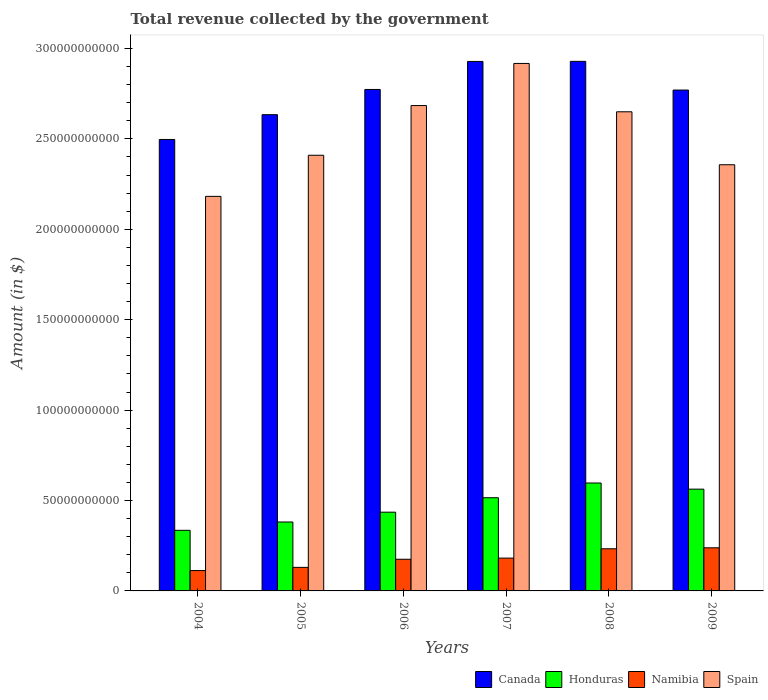How many groups of bars are there?
Offer a very short reply. 6. How many bars are there on the 4th tick from the right?
Your answer should be very brief. 4. What is the total revenue collected by the government in Spain in 2006?
Ensure brevity in your answer.  2.68e+11. Across all years, what is the maximum total revenue collected by the government in Canada?
Ensure brevity in your answer.  2.93e+11. Across all years, what is the minimum total revenue collected by the government in Honduras?
Your answer should be very brief. 3.35e+1. In which year was the total revenue collected by the government in Canada maximum?
Provide a short and direct response. 2008. In which year was the total revenue collected by the government in Canada minimum?
Your response must be concise. 2004. What is the total total revenue collected by the government in Honduras in the graph?
Ensure brevity in your answer.  2.83e+11. What is the difference between the total revenue collected by the government in Canada in 2004 and that in 2009?
Provide a succinct answer. -2.73e+1. What is the difference between the total revenue collected by the government in Canada in 2008 and the total revenue collected by the government in Namibia in 2009?
Offer a terse response. 2.69e+11. What is the average total revenue collected by the government in Spain per year?
Your answer should be very brief. 2.53e+11. In the year 2008, what is the difference between the total revenue collected by the government in Honduras and total revenue collected by the government in Spain?
Ensure brevity in your answer.  -2.05e+11. In how many years, is the total revenue collected by the government in Spain greater than 250000000000 $?
Give a very brief answer. 3. What is the ratio of the total revenue collected by the government in Spain in 2004 to that in 2006?
Keep it short and to the point. 0.81. Is the total revenue collected by the government in Honduras in 2006 less than that in 2008?
Your answer should be very brief. Yes. What is the difference between the highest and the second highest total revenue collected by the government in Spain?
Offer a terse response. 2.33e+1. What is the difference between the highest and the lowest total revenue collected by the government in Honduras?
Your response must be concise. 2.62e+1. What does the 4th bar from the left in 2009 represents?
Give a very brief answer. Spain. Is it the case that in every year, the sum of the total revenue collected by the government in Spain and total revenue collected by the government in Namibia is greater than the total revenue collected by the government in Canada?
Ensure brevity in your answer.  No. How many bars are there?
Offer a terse response. 24. Are all the bars in the graph horizontal?
Provide a succinct answer. No. How many years are there in the graph?
Provide a succinct answer. 6. Does the graph contain any zero values?
Offer a very short reply. No. Where does the legend appear in the graph?
Your answer should be very brief. Bottom right. What is the title of the graph?
Provide a short and direct response. Total revenue collected by the government. What is the label or title of the Y-axis?
Your answer should be very brief. Amount (in $). What is the Amount (in $) in Canada in 2004?
Give a very brief answer. 2.50e+11. What is the Amount (in $) of Honduras in 2004?
Make the answer very short. 3.35e+1. What is the Amount (in $) in Namibia in 2004?
Provide a succinct answer. 1.13e+1. What is the Amount (in $) of Spain in 2004?
Give a very brief answer. 2.18e+11. What is the Amount (in $) of Canada in 2005?
Offer a terse response. 2.63e+11. What is the Amount (in $) of Honduras in 2005?
Ensure brevity in your answer.  3.81e+1. What is the Amount (in $) of Namibia in 2005?
Provide a succinct answer. 1.30e+1. What is the Amount (in $) in Spain in 2005?
Provide a short and direct response. 2.41e+11. What is the Amount (in $) in Canada in 2006?
Your answer should be compact. 2.77e+11. What is the Amount (in $) of Honduras in 2006?
Provide a short and direct response. 4.35e+1. What is the Amount (in $) in Namibia in 2006?
Keep it short and to the point. 1.75e+1. What is the Amount (in $) in Spain in 2006?
Keep it short and to the point. 2.68e+11. What is the Amount (in $) in Canada in 2007?
Your response must be concise. 2.93e+11. What is the Amount (in $) in Honduras in 2007?
Offer a terse response. 5.15e+1. What is the Amount (in $) in Namibia in 2007?
Ensure brevity in your answer.  1.82e+1. What is the Amount (in $) in Spain in 2007?
Your answer should be compact. 2.92e+11. What is the Amount (in $) in Canada in 2008?
Your answer should be very brief. 2.93e+11. What is the Amount (in $) of Honduras in 2008?
Make the answer very short. 5.97e+1. What is the Amount (in $) in Namibia in 2008?
Offer a very short reply. 2.33e+1. What is the Amount (in $) of Spain in 2008?
Offer a terse response. 2.65e+11. What is the Amount (in $) in Canada in 2009?
Ensure brevity in your answer.  2.77e+11. What is the Amount (in $) of Honduras in 2009?
Give a very brief answer. 5.63e+1. What is the Amount (in $) of Namibia in 2009?
Ensure brevity in your answer.  2.38e+1. What is the Amount (in $) of Spain in 2009?
Your response must be concise. 2.36e+11. Across all years, what is the maximum Amount (in $) of Canada?
Provide a succinct answer. 2.93e+11. Across all years, what is the maximum Amount (in $) of Honduras?
Offer a terse response. 5.97e+1. Across all years, what is the maximum Amount (in $) in Namibia?
Your answer should be compact. 2.38e+1. Across all years, what is the maximum Amount (in $) in Spain?
Give a very brief answer. 2.92e+11. Across all years, what is the minimum Amount (in $) in Canada?
Provide a succinct answer. 2.50e+11. Across all years, what is the minimum Amount (in $) in Honduras?
Provide a succinct answer. 3.35e+1. Across all years, what is the minimum Amount (in $) of Namibia?
Give a very brief answer. 1.13e+1. Across all years, what is the minimum Amount (in $) in Spain?
Offer a very short reply. 2.18e+11. What is the total Amount (in $) of Canada in the graph?
Your answer should be very brief. 1.65e+12. What is the total Amount (in $) in Honduras in the graph?
Your response must be concise. 2.83e+11. What is the total Amount (in $) in Namibia in the graph?
Make the answer very short. 1.07e+11. What is the total Amount (in $) of Spain in the graph?
Give a very brief answer. 1.52e+12. What is the difference between the Amount (in $) of Canada in 2004 and that in 2005?
Make the answer very short. -1.37e+1. What is the difference between the Amount (in $) of Honduras in 2004 and that in 2005?
Your answer should be compact. -4.61e+09. What is the difference between the Amount (in $) in Namibia in 2004 and that in 2005?
Keep it short and to the point. -1.77e+09. What is the difference between the Amount (in $) of Spain in 2004 and that in 2005?
Your answer should be very brief. -2.27e+1. What is the difference between the Amount (in $) of Canada in 2004 and that in 2006?
Offer a very short reply. -2.77e+1. What is the difference between the Amount (in $) of Honduras in 2004 and that in 2006?
Your response must be concise. -1.00e+1. What is the difference between the Amount (in $) of Namibia in 2004 and that in 2006?
Offer a very short reply. -6.26e+09. What is the difference between the Amount (in $) in Spain in 2004 and that in 2006?
Keep it short and to the point. -5.02e+1. What is the difference between the Amount (in $) of Canada in 2004 and that in 2007?
Offer a very short reply. -4.32e+1. What is the difference between the Amount (in $) of Honduras in 2004 and that in 2007?
Keep it short and to the point. -1.80e+1. What is the difference between the Amount (in $) of Namibia in 2004 and that in 2007?
Make the answer very short. -6.89e+09. What is the difference between the Amount (in $) in Spain in 2004 and that in 2007?
Your answer should be very brief. -7.35e+1. What is the difference between the Amount (in $) of Canada in 2004 and that in 2008?
Your answer should be compact. -4.32e+1. What is the difference between the Amount (in $) of Honduras in 2004 and that in 2008?
Offer a very short reply. -2.62e+1. What is the difference between the Amount (in $) in Namibia in 2004 and that in 2008?
Make the answer very short. -1.21e+1. What is the difference between the Amount (in $) in Spain in 2004 and that in 2008?
Provide a short and direct response. -4.68e+1. What is the difference between the Amount (in $) in Canada in 2004 and that in 2009?
Give a very brief answer. -2.73e+1. What is the difference between the Amount (in $) in Honduras in 2004 and that in 2009?
Give a very brief answer. -2.28e+1. What is the difference between the Amount (in $) of Namibia in 2004 and that in 2009?
Provide a succinct answer. -1.26e+1. What is the difference between the Amount (in $) in Spain in 2004 and that in 2009?
Offer a terse response. -1.75e+1. What is the difference between the Amount (in $) of Canada in 2005 and that in 2006?
Provide a succinct answer. -1.40e+1. What is the difference between the Amount (in $) of Honduras in 2005 and that in 2006?
Provide a short and direct response. -5.42e+09. What is the difference between the Amount (in $) of Namibia in 2005 and that in 2006?
Offer a terse response. -4.49e+09. What is the difference between the Amount (in $) in Spain in 2005 and that in 2006?
Offer a very short reply. -2.75e+1. What is the difference between the Amount (in $) of Canada in 2005 and that in 2007?
Offer a very short reply. -2.94e+1. What is the difference between the Amount (in $) of Honduras in 2005 and that in 2007?
Offer a very short reply. -1.34e+1. What is the difference between the Amount (in $) in Namibia in 2005 and that in 2007?
Your answer should be very brief. -5.12e+09. What is the difference between the Amount (in $) in Spain in 2005 and that in 2007?
Offer a terse response. -5.08e+1. What is the difference between the Amount (in $) of Canada in 2005 and that in 2008?
Make the answer very short. -2.95e+1. What is the difference between the Amount (in $) of Honduras in 2005 and that in 2008?
Keep it short and to the point. -2.16e+1. What is the difference between the Amount (in $) in Namibia in 2005 and that in 2008?
Your answer should be compact. -1.03e+1. What is the difference between the Amount (in $) in Spain in 2005 and that in 2008?
Offer a terse response. -2.40e+1. What is the difference between the Amount (in $) of Canada in 2005 and that in 2009?
Your answer should be very brief. -1.36e+1. What is the difference between the Amount (in $) in Honduras in 2005 and that in 2009?
Give a very brief answer. -1.82e+1. What is the difference between the Amount (in $) in Namibia in 2005 and that in 2009?
Ensure brevity in your answer.  -1.08e+1. What is the difference between the Amount (in $) of Spain in 2005 and that in 2009?
Provide a short and direct response. 5.25e+09. What is the difference between the Amount (in $) in Canada in 2006 and that in 2007?
Your response must be concise. -1.55e+1. What is the difference between the Amount (in $) of Honduras in 2006 and that in 2007?
Ensure brevity in your answer.  -7.99e+09. What is the difference between the Amount (in $) in Namibia in 2006 and that in 2007?
Provide a succinct answer. -6.34e+08. What is the difference between the Amount (in $) in Spain in 2006 and that in 2007?
Keep it short and to the point. -2.33e+1. What is the difference between the Amount (in $) in Canada in 2006 and that in 2008?
Your response must be concise. -1.55e+1. What is the difference between the Amount (in $) in Honduras in 2006 and that in 2008?
Keep it short and to the point. -1.61e+1. What is the difference between the Amount (in $) of Namibia in 2006 and that in 2008?
Offer a very short reply. -5.80e+09. What is the difference between the Amount (in $) of Spain in 2006 and that in 2008?
Make the answer very short. 3.45e+09. What is the difference between the Amount (in $) of Canada in 2006 and that in 2009?
Provide a short and direct response. 3.30e+08. What is the difference between the Amount (in $) of Honduras in 2006 and that in 2009?
Your answer should be compact. -1.27e+1. What is the difference between the Amount (in $) in Namibia in 2006 and that in 2009?
Your response must be concise. -6.33e+09. What is the difference between the Amount (in $) in Spain in 2006 and that in 2009?
Offer a very short reply. 3.27e+1. What is the difference between the Amount (in $) of Canada in 2007 and that in 2008?
Offer a terse response. -5.20e+07. What is the difference between the Amount (in $) of Honduras in 2007 and that in 2008?
Ensure brevity in your answer.  -8.15e+09. What is the difference between the Amount (in $) in Namibia in 2007 and that in 2008?
Your answer should be very brief. -5.16e+09. What is the difference between the Amount (in $) in Spain in 2007 and that in 2008?
Offer a terse response. 2.67e+1. What is the difference between the Amount (in $) of Canada in 2007 and that in 2009?
Keep it short and to the point. 1.58e+1. What is the difference between the Amount (in $) in Honduras in 2007 and that in 2009?
Offer a very short reply. -4.75e+09. What is the difference between the Amount (in $) of Namibia in 2007 and that in 2009?
Make the answer very short. -5.70e+09. What is the difference between the Amount (in $) of Spain in 2007 and that in 2009?
Give a very brief answer. 5.60e+1. What is the difference between the Amount (in $) in Canada in 2008 and that in 2009?
Provide a succinct answer. 1.59e+1. What is the difference between the Amount (in $) in Honduras in 2008 and that in 2009?
Keep it short and to the point. 3.40e+09. What is the difference between the Amount (in $) in Namibia in 2008 and that in 2009?
Ensure brevity in your answer.  -5.30e+08. What is the difference between the Amount (in $) in Spain in 2008 and that in 2009?
Give a very brief answer. 2.93e+1. What is the difference between the Amount (in $) of Canada in 2004 and the Amount (in $) of Honduras in 2005?
Offer a terse response. 2.12e+11. What is the difference between the Amount (in $) in Canada in 2004 and the Amount (in $) in Namibia in 2005?
Your answer should be very brief. 2.37e+11. What is the difference between the Amount (in $) in Canada in 2004 and the Amount (in $) in Spain in 2005?
Your response must be concise. 8.73e+09. What is the difference between the Amount (in $) in Honduras in 2004 and the Amount (in $) in Namibia in 2005?
Your response must be concise. 2.05e+1. What is the difference between the Amount (in $) of Honduras in 2004 and the Amount (in $) of Spain in 2005?
Your answer should be compact. -2.07e+11. What is the difference between the Amount (in $) in Namibia in 2004 and the Amount (in $) in Spain in 2005?
Offer a very short reply. -2.30e+11. What is the difference between the Amount (in $) in Canada in 2004 and the Amount (in $) in Honduras in 2006?
Your answer should be compact. 2.06e+11. What is the difference between the Amount (in $) of Canada in 2004 and the Amount (in $) of Namibia in 2006?
Give a very brief answer. 2.32e+11. What is the difference between the Amount (in $) in Canada in 2004 and the Amount (in $) in Spain in 2006?
Provide a short and direct response. -1.88e+1. What is the difference between the Amount (in $) in Honduras in 2004 and the Amount (in $) in Namibia in 2006?
Give a very brief answer. 1.60e+1. What is the difference between the Amount (in $) in Honduras in 2004 and the Amount (in $) in Spain in 2006?
Provide a short and direct response. -2.35e+11. What is the difference between the Amount (in $) of Namibia in 2004 and the Amount (in $) of Spain in 2006?
Your answer should be compact. -2.57e+11. What is the difference between the Amount (in $) of Canada in 2004 and the Amount (in $) of Honduras in 2007?
Keep it short and to the point. 1.98e+11. What is the difference between the Amount (in $) in Canada in 2004 and the Amount (in $) in Namibia in 2007?
Provide a short and direct response. 2.32e+11. What is the difference between the Amount (in $) in Canada in 2004 and the Amount (in $) in Spain in 2007?
Your answer should be compact. -4.21e+1. What is the difference between the Amount (in $) of Honduras in 2004 and the Amount (in $) of Namibia in 2007?
Offer a very short reply. 1.54e+1. What is the difference between the Amount (in $) of Honduras in 2004 and the Amount (in $) of Spain in 2007?
Your response must be concise. -2.58e+11. What is the difference between the Amount (in $) in Namibia in 2004 and the Amount (in $) in Spain in 2007?
Your answer should be compact. -2.80e+11. What is the difference between the Amount (in $) in Canada in 2004 and the Amount (in $) in Honduras in 2008?
Offer a very short reply. 1.90e+11. What is the difference between the Amount (in $) in Canada in 2004 and the Amount (in $) in Namibia in 2008?
Make the answer very short. 2.26e+11. What is the difference between the Amount (in $) in Canada in 2004 and the Amount (in $) in Spain in 2008?
Keep it short and to the point. -1.53e+1. What is the difference between the Amount (in $) in Honduras in 2004 and the Amount (in $) in Namibia in 2008?
Provide a short and direct response. 1.02e+1. What is the difference between the Amount (in $) in Honduras in 2004 and the Amount (in $) in Spain in 2008?
Make the answer very short. -2.31e+11. What is the difference between the Amount (in $) of Namibia in 2004 and the Amount (in $) of Spain in 2008?
Your response must be concise. -2.54e+11. What is the difference between the Amount (in $) of Canada in 2004 and the Amount (in $) of Honduras in 2009?
Keep it short and to the point. 1.93e+11. What is the difference between the Amount (in $) in Canada in 2004 and the Amount (in $) in Namibia in 2009?
Your response must be concise. 2.26e+11. What is the difference between the Amount (in $) of Canada in 2004 and the Amount (in $) of Spain in 2009?
Your answer should be very brief. 1.40e+1. What is the difference between the Amount (in $) of Honduras in 2004 and the Amount (in $) of Namibia in 2009?
Keep it short and to the point. 9.67e+09. What is the difference between the Amount (in $) in Honduras in 2004 and the Amount (in $) in Spain in 2009?
Your response must be concise. -2.02e+11. What is the difference between the Amount (in $) of Namibia in 2004 and the Amount (in $) of Spain in 2009?
Your answer should be very brief. -2.24e+11. What is the difference between the Amount (in $) in Canada in 2005 and the Amount (in $) in Honduras in 2006?
Your response must be concise. 2.20e+11. What is the difference between the Amount (in $) in Canada in 2005 and the Amount (in $) in Namibia in 2006?
Give a very brief answer. 2.46e+11. What is the difference between the Amount (in $) of Canada in 2005 and the Amount (in $) of Spain in 2006?
Your response must be concise. -5.04e+09. What is the difference between the Amount (in $) in Honduras in 2005 and the Amount (in $) in Namibia in 2006?
Give a very brief answer. 2.06e+1. What is the difference between the Amount (in $) in Honduras in 2005 and the Amount (in $) in Spain in 2006?
Keep it short and to the point. -2.30e+11. What is the difference between the Amount (in $) in Namibia in 2005 and the Amount (in $) in Spain in 2006?
Offer a very short reply. -2.55e+11. What is the difference between the Amount (in $) in Canada in 2005 and the Amount (in $) in Honduras in 2007?
Keep it short and to the point. 2.12e+11. What is the difference between the Amount (in $) of Canada in 2005 and the Amount (in $) of Namibia in 2007?
Your response must be concise. 2.45e+11. What is the difference between the Amount (in $) in Canada in 2005 and the Amount (in $) in Spain in 2007?
Ensure brevity in your answer.  -2.83e+1. What is the difference between the Amount (in $) in Honduras in 2005 and the Amount (in $) in Namibia in 2007?
Your response must be concise. 2.00e+1. What is the difference between the Amount (in $) of Honduras in 2005 and the Amount (in $) of Spain in 2007?
Keep it short and to the point. -2.54e+11. What is the difference between the Amount (in $) in Namibia in 2005 and the Amount (in $) in Spain in 2007?
Provide a succinct answer. -2.79e+11. What is the difference between the Amount (in $) in Canada in 2005 and the Amount (in $) in Honduras in 2008?
Your answer should be very brief. 2.04e+11. What is the difference between the Amount (in $) of Canada in 2005 and the Amount (in $) of Namibia in 2008?
Offer a terse response. 2.40e+11. What is the difference between the Amount (in $) in Canada in 2005 and the Amount (in $) in Spain in 2008?
Ensure brevity in your answer.  -1.60e+09. What is the difference between the Amount (in $) of Honduras in 2005 and the Amount (in $) of Namibia in 2008?
Offer a very short reply. 1.48e+1. What is the difference between the Amount (in $) of Honduras in 2005 and the Amount (in $) of Spain in 2008?
Offer a terse response. -2.27e+11. What is the difference between the Amount (in $) of Namibia in 2005 and the Amount (in $) of Spain in 2008?
Provide a succinct answer. -2.52e+11. What is the difference between the Amount (in $) in Canada in 2005 and the Amount (in $) in Honduras in 2009?
Your answer should be compact. 2.07e+11. What is the difference between the Amount (in $) of Canada in 2005 and the Amount (in $) of Namibia in 2009?
Provide a short and direct response. 2.40e+11. What is the difference between the Amount (in $) in Canada in 2005 and the Amount (in $) in Spain in 2009?
Keep it short and to the point. 2.77e+1. What is the difference between the Amount (in $) of Honduras in 2005 and the Amount (in $) of Namibia in 2009?
Offer a terse response. 1.43e+1. What is the difference between the Amount (in $) of Honduras in 2005 and the Amount (in $) of Spain in 2009?
Provide a succinct answer. -1.98e+11. What is the difference between the Amount (in $) in Namibia in 2005 and the Amount (in $) in Spain in 2009?
Ensure brevity in your answer.  -2.23e+11. What is the difference between the Amount (in $) of Canada in 2006 and the Amount (in $) of Honduras in 2007?
Keep it short and to the point. 2.26e+11. What is the difference between the Amount (in $) of Canada in 2006 and the Amount (in $) of Namibia in 2007?
Ensure brevity in your answer.  2.59e+11. What is the difference between the Amount (in $) of Canada in 2006 and the Amount (in $) of Spain in 2007?
Give a very brief answer. -1.44e+1. What is the difference between the Amount (in $) in Honduras in 2006 and the Amount (in $) in Namibia in 2007?
Make the answer very short. 2.54e+1. What is the difference between the Amount (in $) in Honduras in 2006 and the Amount (in $) in Spain in 2007?
Keep it short and to the point. -2.48e+11. What is the difference between the Amount (in $) in Namibia in 2006 and the Amount (in $) in Spain in 2007?
Offer a terse response. -2.74e+11. What is the difference between the Amount (in $) of Canada in 2006 and the Amount (in $) of Honduras in 2008?
Ensure brevity in your answer.  2.18e+11. What is the difference between the Amount (in $) in Canada in 2006 and the Amount (in $) in Namibia in 2008?
Offer a very short reply. 2.54e+11. What is the difference between the Amount (in $) of Canada in 2006 and the Amount (in $) of Spain in 2008?
Your answer should be compact. 1.24e+1. What is the difference between the Amount (in $) in Honduras in 2006 and the Amount (in $) in Namibia in 2008?
Offer a very short reply. 2.02e+1. What is the difference between the Amount (in $) in Honduras in 2006 and the Amount (in $) in Spain in 2008?
Offer a terse response. -2.21e+11. What is the difference between the Amount (in $) in Namibia in 2006 and the Amount (in $) in Spain in 2008?
Keep it short and to the point. -2.47e+11. What is the difference between the Amount (in $) in Canada in 2006 and the Amount (in $) in Honduras in 2009?
Provide a succinct answer. 2.21e+11. What is the difference between the Amount (in $) in Canada in 2006 and the Amount (in $) in Namibia in 2009?
Make the answer very short. 2.54e+11. What is the difference between the Amount (in $) in Canada in 2006 and the Amount (in $) in Spain in 2009?
Offer a very short reply. 4.16e+1. What is the difference between the Amount (in $) of Honduras in 2006 and the Amount (in $) of Namibia in 2009?
Keep it short and to the point. 1.97e+1. What is the difference between the Amount (in $) in Honduras in 2006 and the Amount (in $) in Spain in 2009?
Your answer should be compact. -1.92e+11. What is the difference between the Amount (in $) of Namibia in 2006 and the Amount (in $) of Spain in 2009?
Offer a very short reply. -2.18e+11. What is the difference between the Amount (in $) of Canada in 2007 and the Amount (in $) of Honduras in 2008?
Your answer should be very brief. 2.33e+11. What is the difference between the Amount (in $) in Canada in 2007 and the Amount (in $) in Namibia in 2008?
Give a very brief answer. 2.70e+11. What is the difference between the Amount (in $) of Canada in 2007 and the Amount (in $) of Spain in 2008?
Offer a very short reply. 2.78e+1. What is the difference between the Amount (in $) of Honduras in 2007 and the Amount (in $) of Namibia in 2008?
Make the answer very short. 2.82e+1. What is the difference between the Amount (in $) in Honduras in 2007 and the Amount (in $) in Spain in 2008?
Provide a short and direct response. -2.13e+11. What is the difference between the Amount (in $) in Namibia in 2007 and the Amount (in $) in Spain in 2008?
Give a very brief answer. -2.47e+11. What is the difference between the Amount (in $) of Canada in 2007 and the Amount (in $) of Honduras in 2009?
Your answer should be very brief. 2.37e+11. What is the difference between the Amount (in $) in Canada in 2007 and the Amount (in $) in Namibia in 2009?
Ensure brevity in your answer.  2.69e+11. What is the difference between the Amount (in $) in Canada in 2007 and the Amount (in $) in Spain in 2009?
Your answer should be very brief. 5.71e+1. What is the difference between the Amount (in $) of Honduras in 2007 and the Amount (in $) of Namibia in 2009?
Provide a succinct answer. 2.77e+1. What is the difference between the Amount (in $) in Honduras in 2007 and the Amount (in $) in Spain in 2009?
Offer a terse response. -1.84e+11. What is the difference between the Amount (in $) of Namibia in 2007 and the Amount (in $) of Spain in 2009?
Offer a very short reply. -2.18e+11. What is the difference between the Amount (in $) of Canada in 2008 and the Amount (in $) of Honduras in 2009?
Provide a succinct answer. 2.37e+11. What is the difference between the Amount (in $) of Canada in 2008 and the Amount (in $) of Namibia in 2009?
Make the answer very short. 2.69e+11. What is the difference between the Amount (in $) of Canada in 2008 and the Amount (in $) of Spain in 2009?
Keep it short and to the point. 5.72e+1. What is the difference between the Amount (in $) of Honduras in 2008 and the Amount (in $) of Namibia in 2009?
Offer a terse response. 3.58e+1. What is the difference between the Amount (in $) of Honduras in 2008 and the Amount (in $) of Spain in 2009?
Your response must be concise. -1.76e+11. What is the difference between the Amount (in $) in Namibia in 2008 and the Amount (in $) in Spain in 2009?
Provide a succinct answer. -2.12e+11. What is the average Amount (in $) in Canada per year?
Your response must be concise. 2.76e+11. What is the average Amount (in $) of Honduras per year?
Ensure brevity in your answer.  4.71e+1. What is the average Amount (in $) of Namibia per year?
Offer a terse response. 1.79e+1. What is the average Amount (in $) of Spain per year?
Provide a short and direct response. 2.53e+11. In the year 2004, what is the difference between the Amount (in $) of Canada and Amount (in $) of Honduras?
Ensure brevity in your answer.  2.16e+11. In the year 2004, what is the difference between the Amount (in $) of Canada and Amount (in $) of Namibia?
Your answer should be very brief. 2.38e+11. In the year 2004, what is the difference between the Amount (in $) in Canada and Amount (in $) in Spain?
Make the answer very short. 3.15e+1. In the year 2004, what is the difference between the Amount (in $) in Honduras and Amount (in $) in Namibia?
Keep it short and to the point. 2.23e+1. In the year 2004, what is the difference between the Amount (in $) in Honduras and Amount (in $) in Spain?
Make the answer very short. -1.85e+11. In the year 2004, what is the difference between the Amount (in $) in Namibia and Amount (in $) in Spain?
Keep it short and to the point. -2.07e+11. In the year 2005, what is the difference between the Amount (in $) in Canada and Amount (in $) in Honduras?
Provide a short and direct response. 2.25e+11. In the year 2005, what is the difference between the Amount (in $) of Canada and Amount (in $) of Namibia?
Keep it short and to the point. 2.50e+11. In the year 2005, what is the difference between the Amount (in $) in Canada and Amount (in $) in Spain?
Make the answer very short. 2.24e+1. In the year 2005, what is the difference between the Amount (in $) of Honduras and Amount (in $) of Namibia?
Your answer should be compact. 2.51e+1. In the year 2005, what is the difference between the Amount (in $) of Honduras and Amount (in $) of Spain?
Give a very brief answer. -2.03e+11. In the year 2005, what is the difference between the Amount (in $) of Namibia and Amount (in $) of Spain?
Keep it short and to the point. -2.28e+11. In the year 2006, what is the difference between the Amount (in $) of Canada and Amount (in $) of Honduras?
Your response must be concise. 2.34e+11. In the year 2006, what is the difference between the Amount (in $) in Canada and Amount (in $) in Namibia?
Provide a short and direct response. 2.60e+11. In the year 2006, what is the difference between the Amount (in $) in Canada and Amount (in $) in Spain?
Offer a very short reply. 8.91e+09. In the year 2006, what is the difference between the Amount (in $) in Honduras and Amount (in $) in Namibia?
Ensure brevity in your answer.  2.60e+1. In the year 2006, what is the difference between the Amount (in $) of Honduras and Amount (in $) of Spain?
Your answer should be compact. -2.25e+11. In the year 2006, what is the difference between the Amount (in $) of Namibia and Amount (in $) of Spain?
Make the answer very short. -2.51e+11. In the year 2007, what is the difference between the Amount (in $) of Canada and Amount (in $) of Honduras?
Keep it short and to the point. 2.41e+11. In the year 2007, what is the difference between the Amount (in $) in Canada and Amount (in $) in Namibia?
Give a very brief answer. 2.75e+11. In the year 2007, what is the difference between the Amount (in $) of Canada and Amount (in $) of Spain?
Your answer should be very brief. 1.10e+09. In the year 2007, what is the difference between the Amount (in $) in Honduras and Amount (in $) in Namibia?
Your response must be concise. 3.34e+1. In the year 2007, what is the difference between the Amount (in $) in Honduras and Amount (in $) in Spain?
Your response must be concise. -2.40e+11. In the year 2007, what is the difference between the Amount (in $) of Namibia and Amount (in $) of Spain?
Keep it short and to the point. -2.74e+11. In the year 2008, what is the difference between the Amount (in $) of Canada and Amount (in $) of Honduras?
Provide a short and direct response. 2.33e+11. In the year 2008, what is the difference between the Amount (in $) in Canada and Amount (in $) in Namibia?
Provide a succinct answer. 2.70e+11. In the year 2008, what is the difference between the Amount (in $) of Canada and Amount (in $) of Spain?
Offer a very short reply. 2.79e+1. In the year 2008, what is the difference between the Amount (in $) in Honduras and Amount (in $) in Namibia?
Offer a very short reply. 3.64e+1. In the year 2008, what is the difference between the Amount (in $) in Honduras and Amount (in $) in Spain?
Make the answer very short. -2.05e+11. In the year 2008, what is the difference between the Amount (in $) in Namibia and Amount (in $) in Spain?
Keep it short and to the point. -2.42e+11. In the year 2009, what is the difference between the Amount (in $) in Canada and Amount (in $) in Honduras?
Your answer should be compact. 2.21e+11. In the year 2009, what is the difference between the Amount (in $) in Canada and Amount (in $) in Namibia?
Give a very brief answer. 2.53e+11. In the year 2009, what is the difference between the Amount (in $) of Canada and Amount (in $) of Spain?
Your answer should be compact. 4.13e+1. In the year 2009, what is the difference between the Amount (in $) in Honduras and Amount (in $) in Namibia?
Ensure brevity in your answer.  3.24e+1. In the year 2009, what is the difference between the Amount (in $) of Honduras and Amount (in $) of Spain?
Your answer should be very brief. -1.79e+11. In the year 2009, what is the difference between the Amount (in $) in Namibia and Amount (in $) in Spain?
Ensure brevity in your answer.  -2.12e+11. What is the ratio of the Amount (in $) of Canada in 2004 to that in 2005?
Provide a short and direct response. 0.95. What is the ratio of the Amount (in $) in Honduras in 2004 to that in 2005?
Provide a succinct answer. 0.88. What is the ratio of the Amount (in $) in Namibia in 2004 to that in 2005?
Give a very brief answer. 0.86. What is the ratio of the Amount (in $) of Spain in 2004 to that in 2005?
Keep it short and to the point. 0.91. What is the ratio of the Amount (in $) of Canada in 2004 to that in 2006?
Give a very brief answer. 0.9. What is the ratio of the Amount (in $) of Honduras in 2004 to that in 2006?
Provide a succinct answer. 0.77. What is the ratio of the Amount (in $) of Namibia in 2004 to that in 2006?
Your answer should be very brief. 0.64. What is the ratio of the Amount (in $) in Spain in 2004 to that in 2006?
Provide a succinct answer. 0.81. What is the ratio of the Amount (in $) of Canada in 2004 to that in 2007?
Offer a very short reply. 0.85. What is the ratio of the Amount (in $) of Honduras in 2004 to that in 2007?
Ensure brevity in your answer.  0.65. What is the ratio of the Amount (in $) in Namibia in 2004 to that in 2007?
Give a very brief answer. 0.62. What is the ratio of the Amount (in $) of Spain in 2004 to that in 2007?
Offer a terse response. 0.75. What is the ratio of the Amount (in $) in Canada in 2004 to that in 2008?
Your response must be concise. 0.85. What is the ratio of the Amount (in $) of Honduras in 2004 to that in 2008?
Your response must be concise. 0.56. What is the ratio of the Amount (in $) of Namibia in 2004 to that in 2008?
Make the answer very short. 0.48. What is the ratio of the Amount (in $) of Spain in 2004 to that in 2008?
Your answer should be compact. 0.82. What is the ratio of the Amount (in $) of Canada in 2004 to that in 2009?
Your response must be concise. 0.9. What is the ratio of the Amount (in $) in Honduras in 2004 to that in 2009?
Give a very brief answer. 0.6. What is the ratio of the Amount (in $) in Namibia in 2004 to that in 2009?
Make the answer very short. 0.47. What is the ratio of the Amount (in $) in Spain in 2004 to that in 2009?
Ensure brevity in your answer.  0.93. What is the ratio of the Amount (in $) in Canada in 2005 to that in 2006?
Provide a succinct answer. 0.95. What is the ratio of the Amount (in $) of Honduras in 2005 to that in 2006?
Your answer should be very brief. 0.88. What is the ratio of the Amount (in $) in Namibia in 2005 to that in 2006?
Your answer should be very brief. 0.74. What is the ratio of the Amount (in $) in Spain in 2005 to that in 2006?
Ensure brevity in your answer.  0.9. What is the ratio of the Amount (in $) of Canada in 2005 to that in 2007?
Give a very brief answer. 0.9. What is the ratio of the Amount (in $) of Honduras in 2005 to that in 2007?
Your answer should be compact. 0.74. What is the ratio of the Amount (in $) in Namibia in 2005 to that in 2007?
Offer a terse response. 0.72. What is the ratio of the Amount (in $) in Spain in 2005 to that in 2007?
Give a very brief answer. 0.83. What is the ratio of the Amount (in $) of Canada in 2005 to that in 2008?
Your response must be concise. 0.9. What is the ratio of the Amount (in $) of Honduras in 2005 to that in 2008?
Give a very brief answer. 0.64. What is the ratio of the Amount (in $) of Namibia in 2005 to that in 2008?
Provide a short and direct response. 0.56. What is the ratio of the Amount (in $) in Spain in 2005 to that in 2008?
Provide a short and direct response. 0.91. What is the ratio of the Amount (in $) of Canada in 2005 to that in 2009?
Keep it short and to the point. 0.95. What is the ratio of the Amount (in $) in Honduras in 2005 to that in 2009?
Offer a very short reply. 0.68. What is the ratio of the Amount (in $) of Namibia in 2005 to that in 2009?
Your answer should be compact. 0.55. What is the ratio of the Amount (in $) in Spain in 2005 to that in 2009?
Your answer should be very brief. 1.02. What is the ratio of the Amount (in $) of Canada in 2006 to that in 2007?
Offer a very short reply. 0.95. What is the ratio of the Amount (in $) in Honduras in 2006 to that in 2007?
Offer a very short reply. 0.84. What is the ratio of the Amount (in $) of Namibia in 2006 to that in 2007?
Provide a short and direct response. 0.97. What is the ratio of the Amount (in $) in Spain in 2006 to that in 2007?
Provide a succinct answer. 0.92. What is the ratio of the Amount (in $) in Canada in 2006 to that in 2008?
Give a very brief answer. 0.95. What is the ratio of the Amount (in $) of Honduras in 2006 to that in 2008?
Your response must be concise. 0.73. What is the ratio of the Amount (in $) of Namibia in 2006 to that in 2008?
Offer a terse response. 0.75. What is the ratio of the Amount (in $) of Spain in 2006 to that in 2008?
Your answer should be compact. 1.01. What is the ratio of the Amount (in $) of Honduras in 2006 to that in 2009?
Provide a short and direct response. 0.77. What is the ratio of the Amount (in $) in Namibia in 2006 to that in 2009?
Your answer should be compact. 0.73. What is the ratio of the Amount (in $) of Spain in 2006 to that in 2009?
Your answer should be compact. 1.14. What is the ratio of the Amount (in $) of Canada in 2007 to that in 2008?
Ensure brevity in your answer.  1. What is the ratio of the Amount (in $) of Honduras in 2007 to that in 2008?
Ensure brevity in your answer.  0.86. What is the ratio of the Amount (in $) of Namibia in 2007 to that in 2008?
Your answer should be very brief. 0.78. What is the ratio of the Amount (in $) of Spain in 2007 to that in 2008?
Give a very brief answer. 1.1. What is the ratio of the Amount (in $) of Canada in 2007 to that in 2009?
Your answer should be very brief. 1.06. What is the ratio of the Amount (in $) of Honduras in 2007 to that in 2009?
Offer a terse response. 0.92. What is the ratio of the Amount (in $) in Namibia in 2007 to that in 2009?
Offer a very short reply. 0.76. What is the ratio of the Amount (in $) of Spain in 2007 to that in 2009?
Your response must be concise. 1.24. What is the ratio of the Amount (in $) of Canada in 2008 to that in 2009?
Your answer should be very brief. 1.06. What is the ratio of the Amount (in $) of Honduras in 2008 to that in 2009?
Offer a terse response. 1.06. What is the ratio of the Amount (in $) of Namibia in 2008 to that in 2009?
Provide a succinct answer. 0.98. What is the ratio of the Amount (in $) of Spain in 2008 to that in 2009?
Offer a terse response. 1.12. What is the difference between the highest and the second highest Amount (in $) of Canada?
Offer a terse response. 5.20e+07. What is the difference between the highest and the second highest Amount (in $) of Honduras?
Your answer should be compact. 3.40e+09. What is the difference between the highest and the second highest Amount (in $) of Namibia?
Keep it short and to the point. 5.30e+08. What is the difference between the highest and the second highest Amount (in $) in Spain?
Make the answer very short. 2.33e+1. What is the difference between the highest and the lowest Amount (in $) of Canada?
Your answer should be very brief. 4.32e+1. What is the difference between the highest and the lowest Amount (in $) of Honduras?
Provide a short and direct response. 2.62e+1. What is the difference between the highest and the lowest Amount (in $) in Namibia?
Provide a succinct answer. 1.26e+1. What is the difference between the highest and the lowest Amount (in $) in Spain?
Your response must be concise. 7.35e+1. 